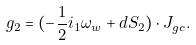<formula> <loc_0><loc_0><loc_500><loc_500>g _ { 2 } = ( - \frac { 1 } { 2 } i _ { 1 } \omega _ { w } + d S _ { 2 } ) \cdot J _ { g c } .</formula> 